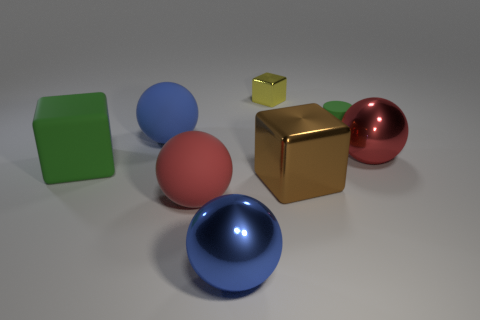There is a big blue sphere that is on the right side of the blue matte ball; how many brown metal cubes are in front of it?
Ensure brevity in your answer.  0. Are any large purple shiny spheres visible?
Offer a very short reply. No. Is there a tiny cylinder that has the same material as the large brown block?
Your answer should be compact. No. Is the number of things right of the blue matte object greater than the number of spheres that are right of the matte cylinder?
Ensure brevity in your answer.  Yes. Do the rubber cylinder and the yellow thing have the same size?
Ensure brevity in your answer.  Yes. What color is the large block that is on the left side of the thing in front of the red matte object?
Keep it short and to the point. Green. The small metal object has what color?
Your answer should be very brief. Yellow. Is there a rubber object that has the same color as the big rubber block?
Make the answer very short. Yes. Is the color of the large cube on the left side of the blue metallic object the same as the small rubber thing?
Your answer should be very brief. Yes. How many things are red spheres that are left of the green cylinder or small things?
Make the answer very short. 3. 